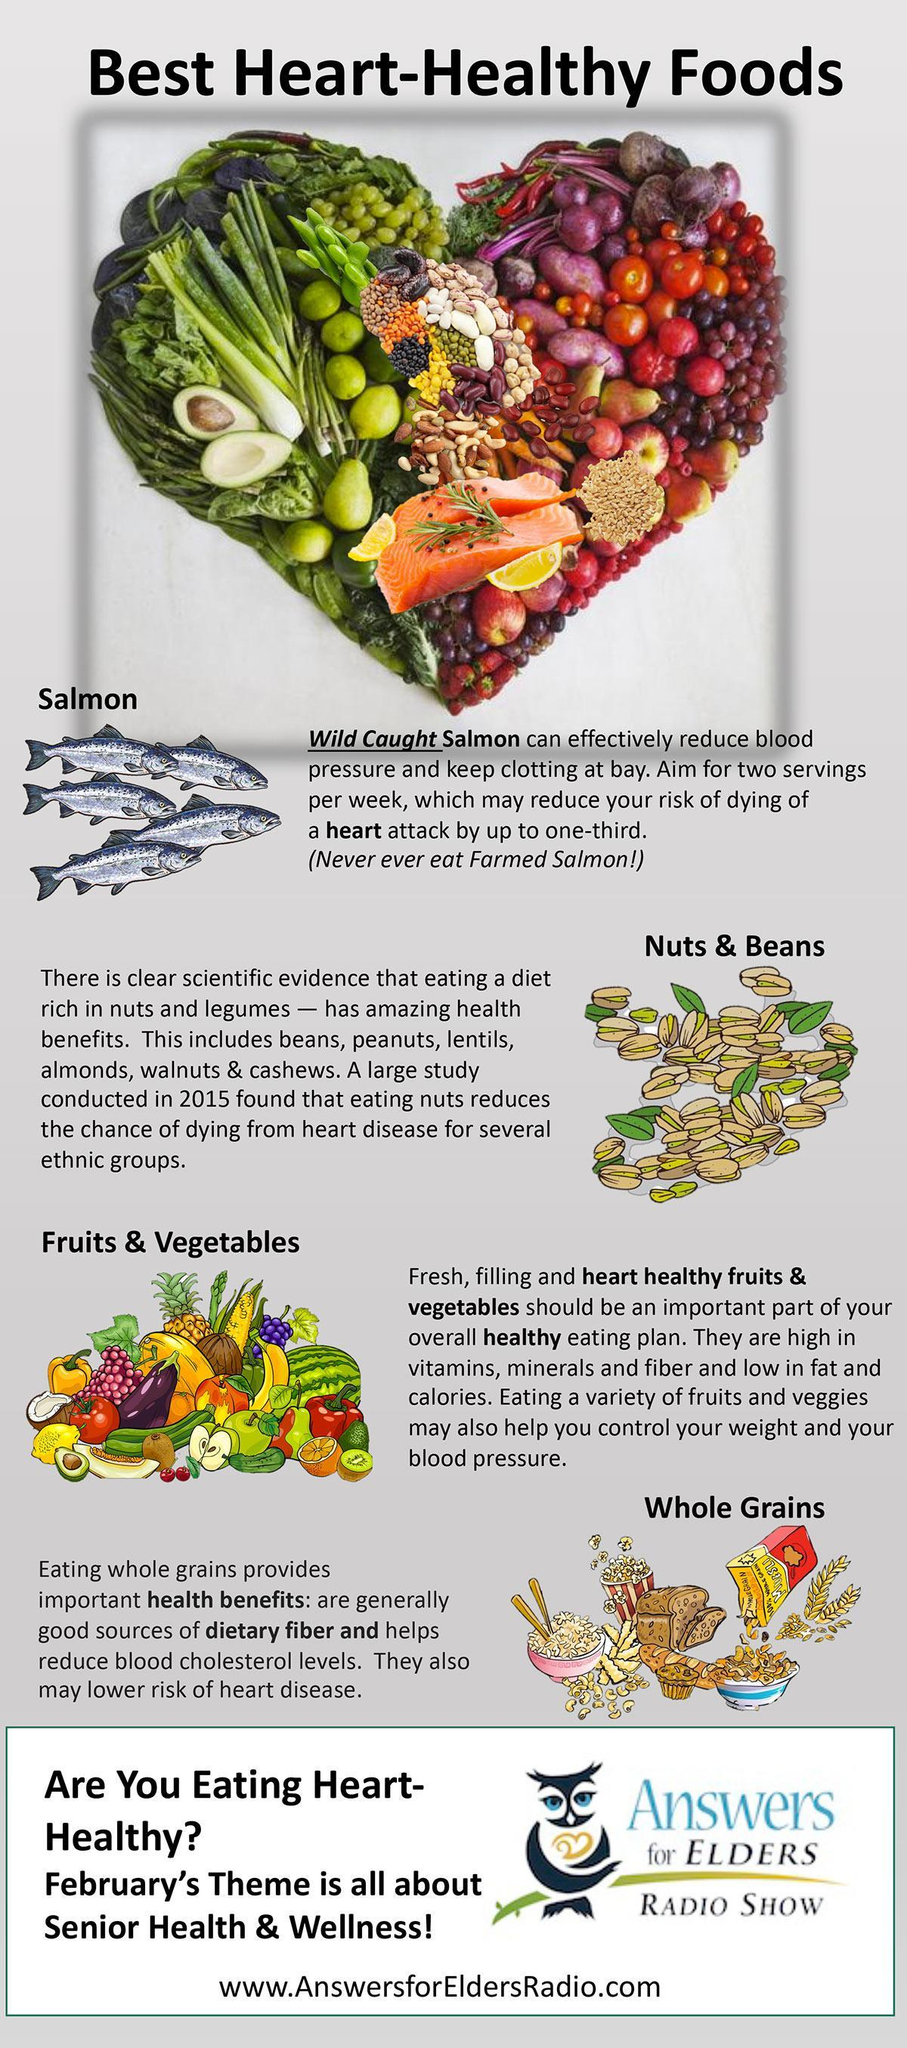Which foods helps lower blood pressure?
Answer the question with a short phrase. Salmon, Fruits & Vegetables How many heart healthy foods are listed? 4 